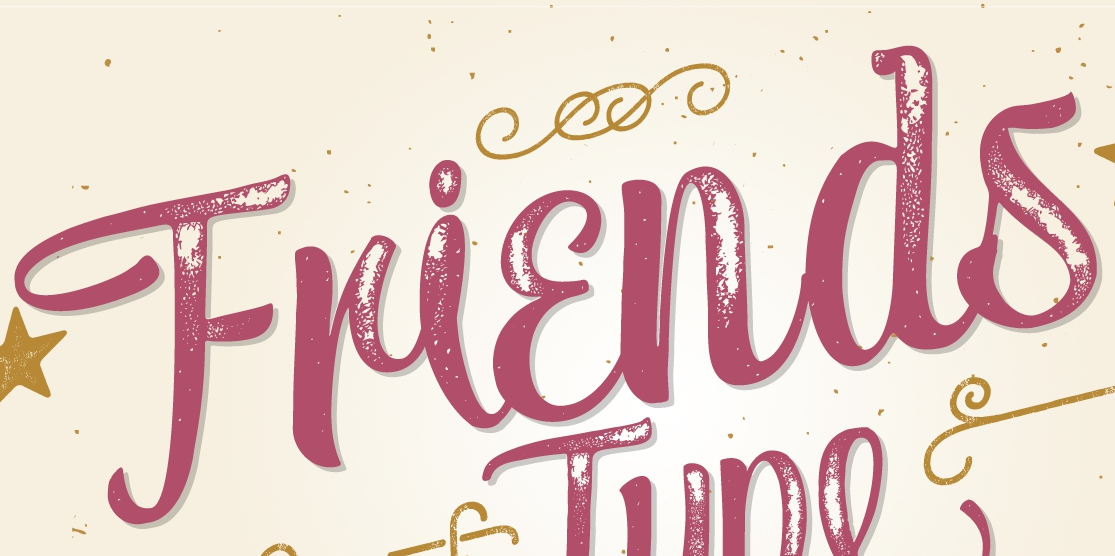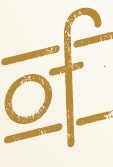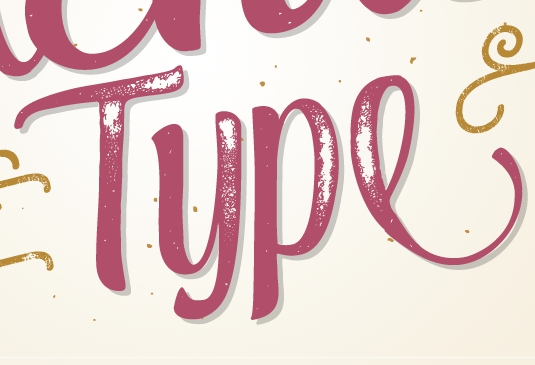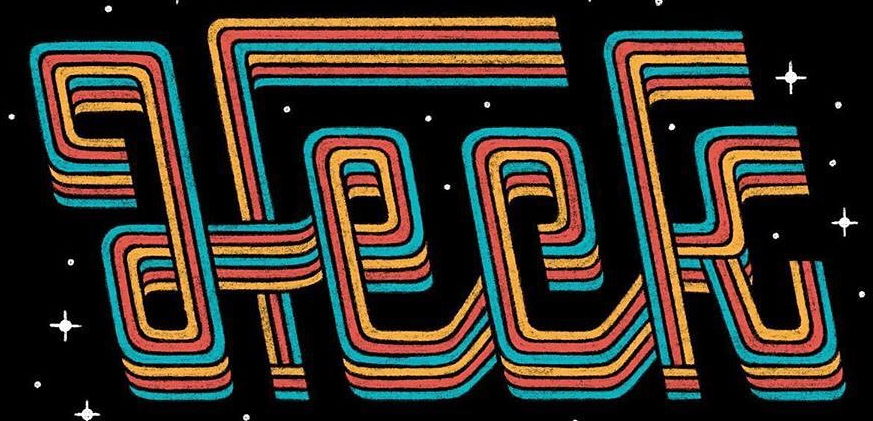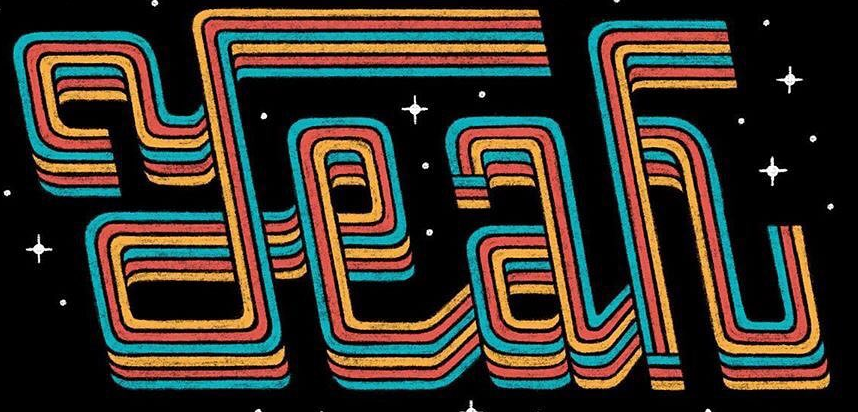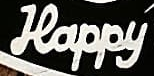Transcribe the words shown in these images in order, separated by a semicolon. Friends; of; Type; Heck; Yeah; Happy 